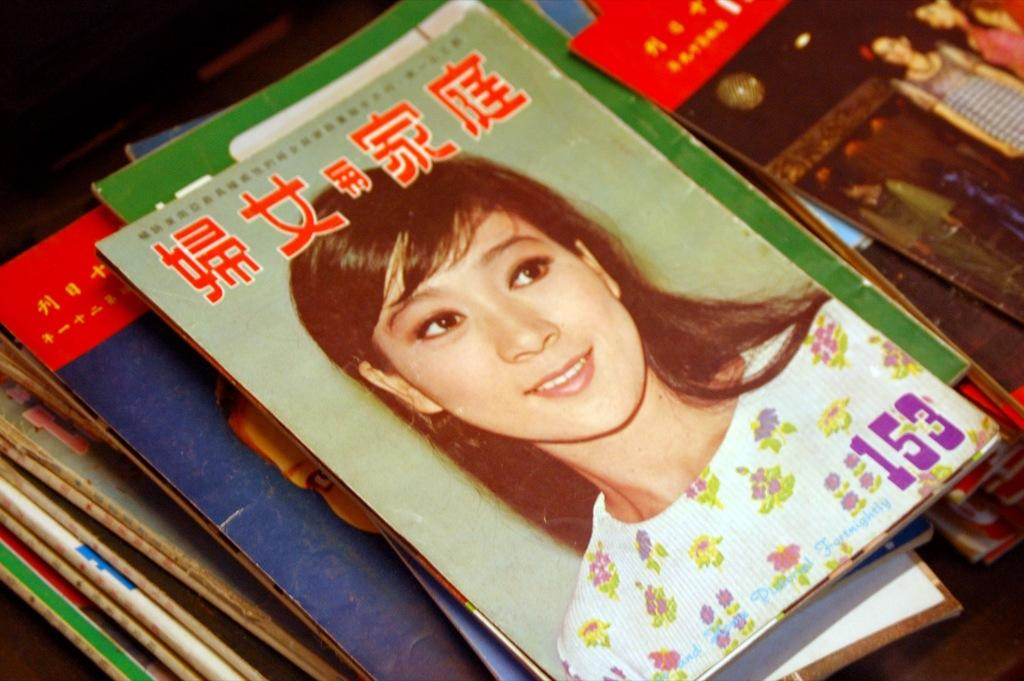What is placed on the table in the image? There is a collection of magazines on a table. Can you describe the image on the first magazine? The first magazine has an image of a woman on it. What type of plane is featured in the image on the second magazine? There is no mention of a second magazine or any image of a plane in the provided facts. 